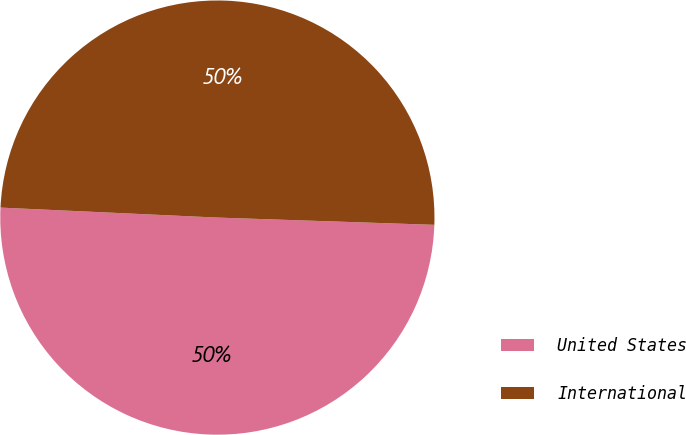Convert chart. <chart><loc_0><loc_0><loc_500><loc_500><pie_chart><fcel>United States<fcel>International<nl><fcel>50.2%<fcel>49.8%<nl></chart> 